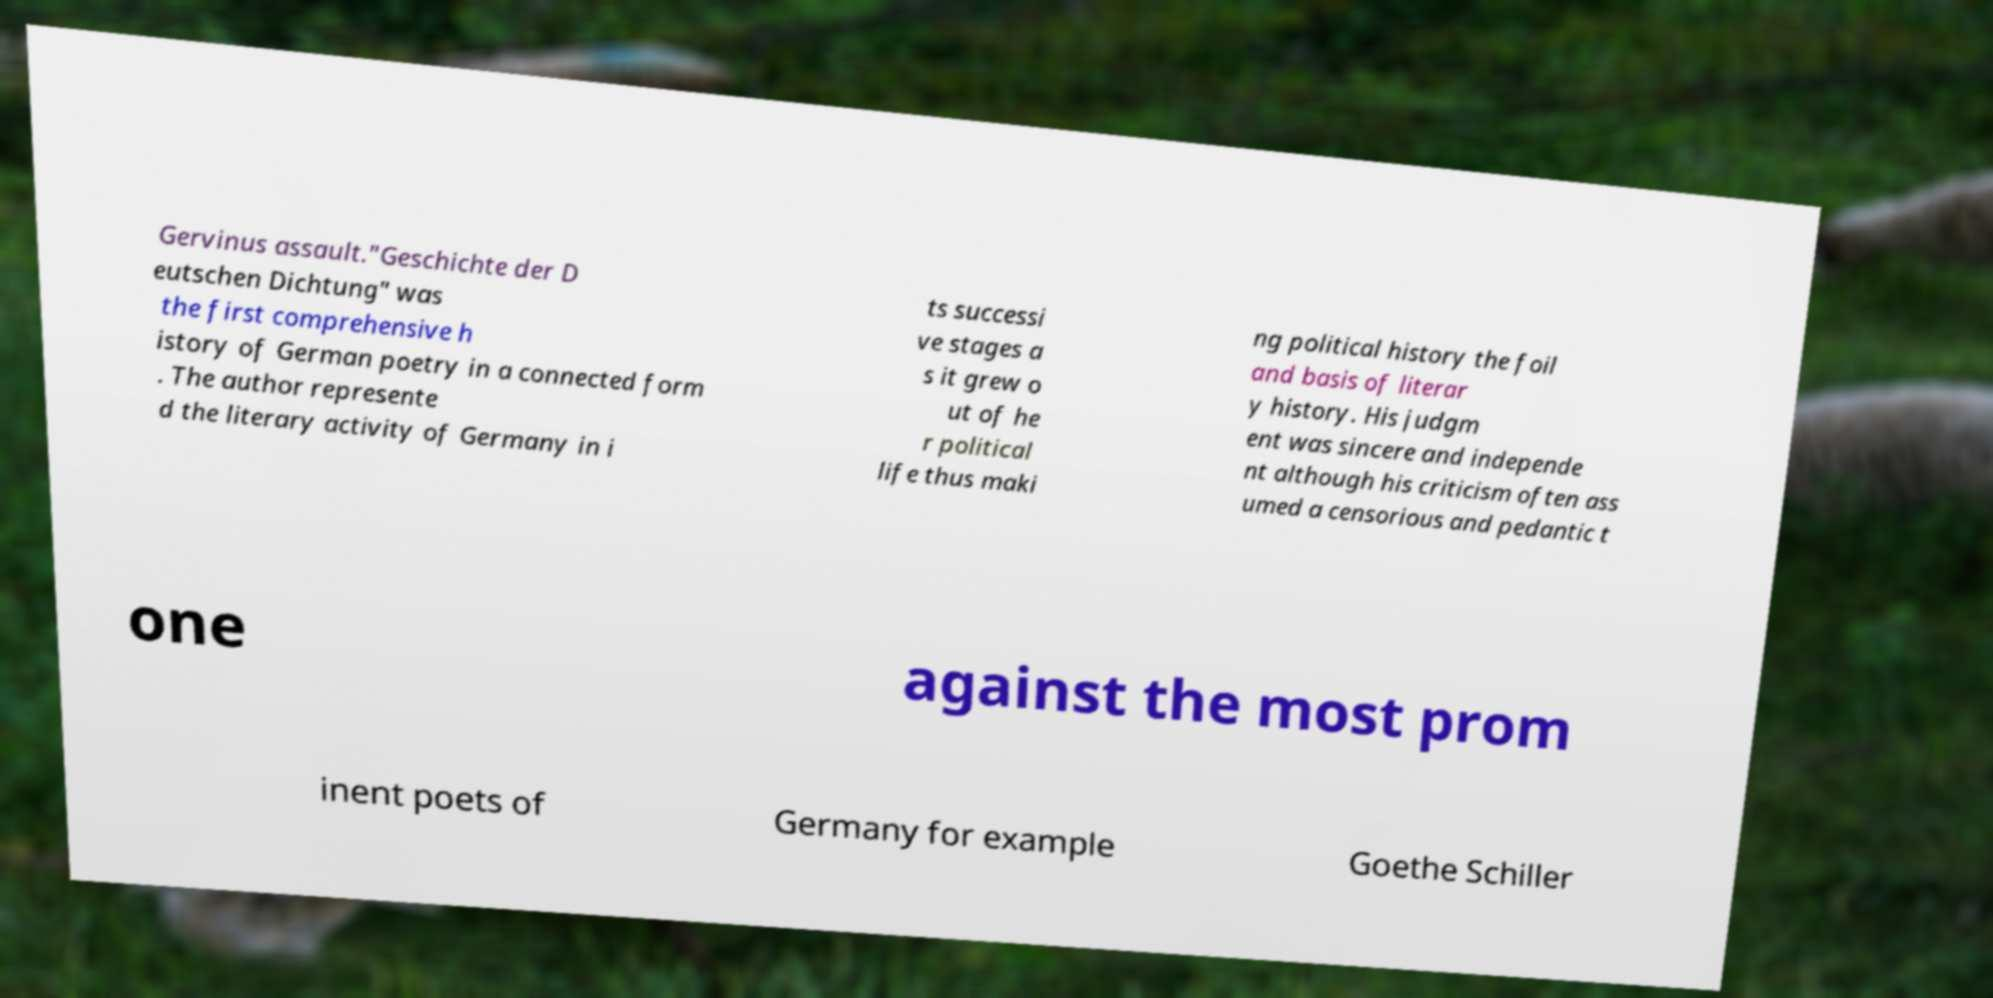Can you accurately transcribe the text from the provided image for me? Gervinus assault."Geschichte der D eutschen Dichtung" was the first comprehensive h istory of German poetry in a connected form . The author represente d the literary activity of Germany in i ts successi ve stages a s it grew o ut of he r political life thus maki ng political history the foil and basis of literar y history. His judgm ent was sincere and independe nt although his criticism often ass umed a censorious and pedantic t one against the most prom inent poets of Germany for example Goethe Schiller 